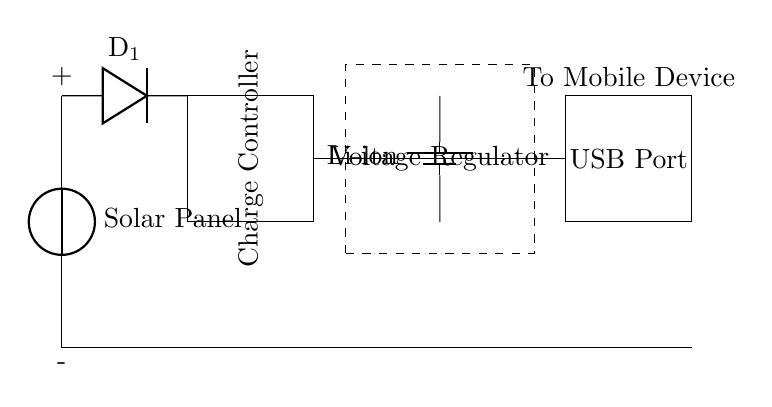What is the main component that captures solar energy? The solar panel is the main component that converts sunlight into electrical energy in this circuit.
Answer: Solar Panel What does the diode in the circuit do? The diode prevents reverse current flow, ensuring that the electrical energy from the solar panel only flows towards the battery and not back into it.
Answer: Prevents reverse current What type of battery is used in this circuit? The circuit specifically includes a lithium-ion battery, which is known for its high energy density and lightweight properties.
Answer: Li-ion How does electrical energy flow from the solar panel to the USB port? Electrical energy flows from the solar panel, through the diode to the charge controller, then to the battery, and finally to the USB port where it can be used to charge mobile devices.
Answer: Through diode, charge controller, battery What is the purpose of the charge controller in the circuit? The charge controller regulates the voltage and current going to the battery, ensuring that it is charged safely without overcharging or discharging too much.
Answer: Regulates voltage and current How many main components are there in this circuit? The circuit consists of five main components: the solar panel, diode, charge controller, battery, and USB port.
Answer: Five Which component connects the battery to the mobile device? The USB port directly connects the battery to the mobile device, allowing for charging through the standard USB interface.
Answer: USB Port 